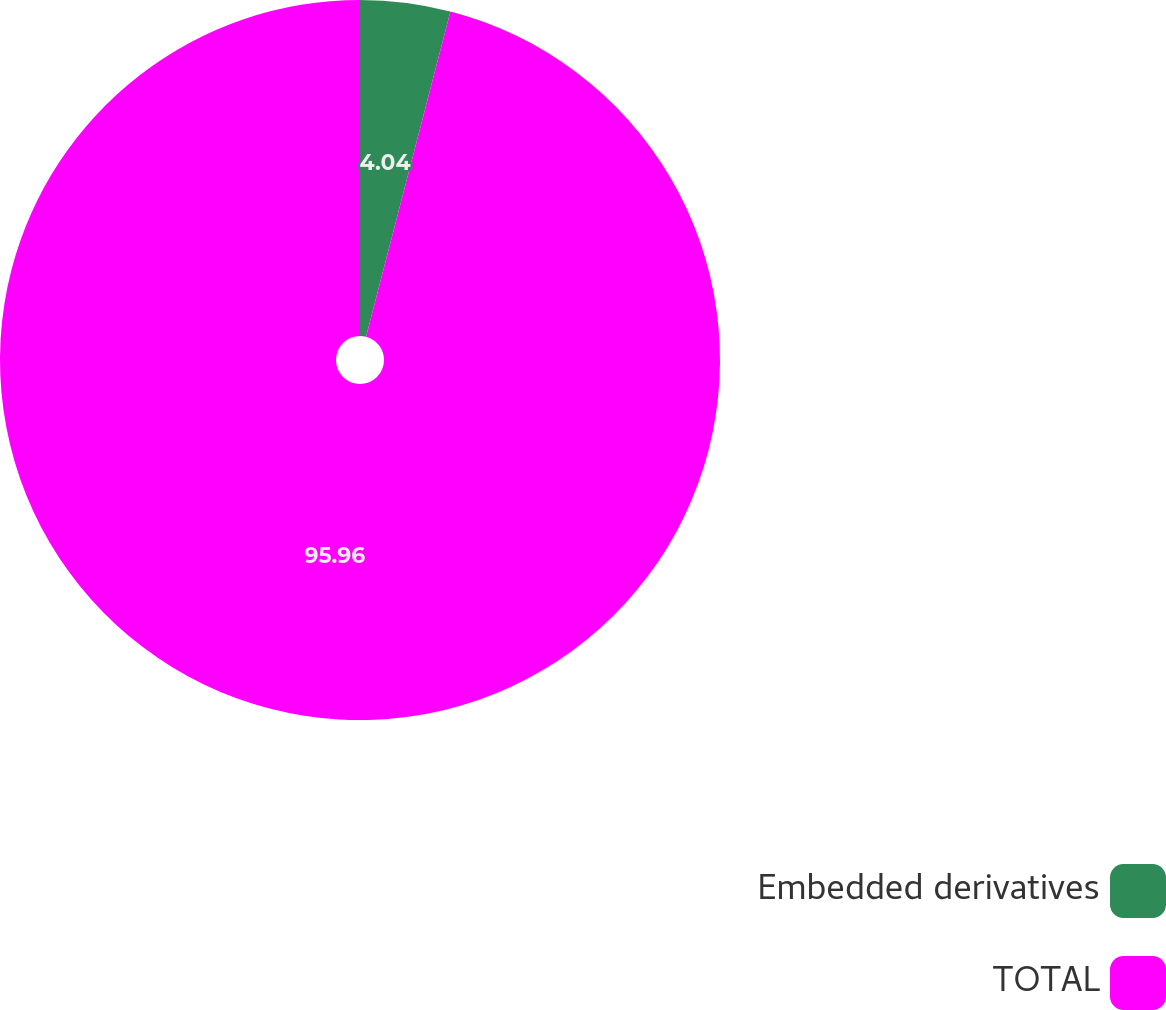<chart> <loc_0><loc_0><loc_500><loc_500><pie_chart><fcel>Embedded derivatives<fcel>TOTAL<nl><fcel>4.04%<fcel>95.96%<nl></chart> 